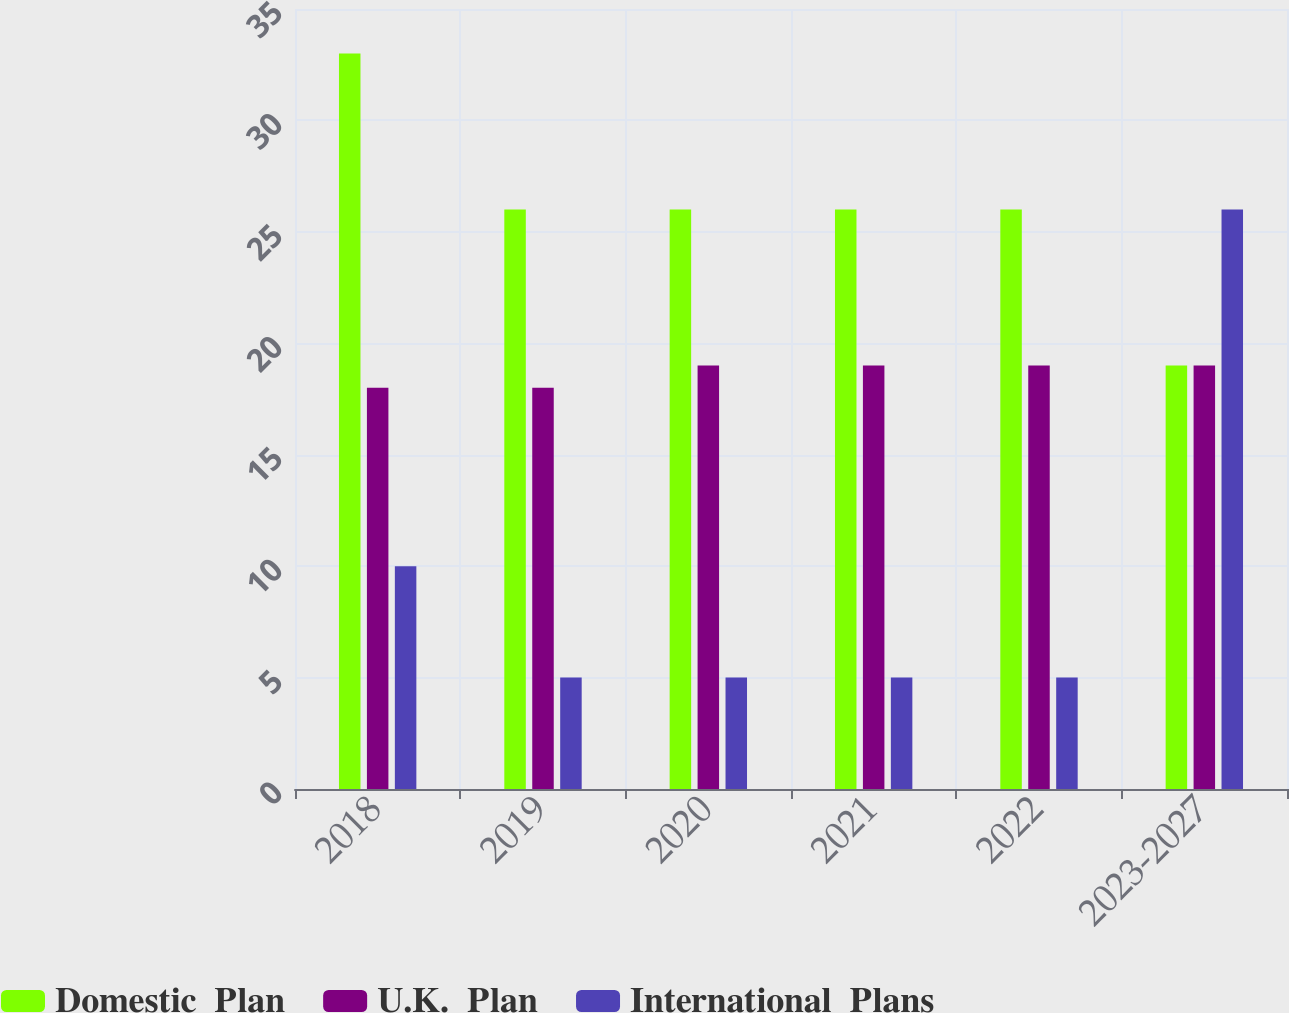Convert chart. <chart><loc_0><loc_0><loc_500><loc_500><stacked_bar_chart><ecel><fcel>2018<fcel>2019<fcel>2020<fcel>2021<fcel>2022<fcel>2023-2027<nl><fcel>Domestic  Plan<fcel>33<fcel>26<fcel>26<fcel>26<fcel>26<fcel>19<nl><fcel>U.K.  Plan<fcel>18<fcel>18<fcel>19<fcel>19<fcel>19<fcel>19<nl><fcel>International  Plans<fcel>10<fcel>5<fcel>5<fcel>5<fcel>5<fcel>26<nl></chart> 